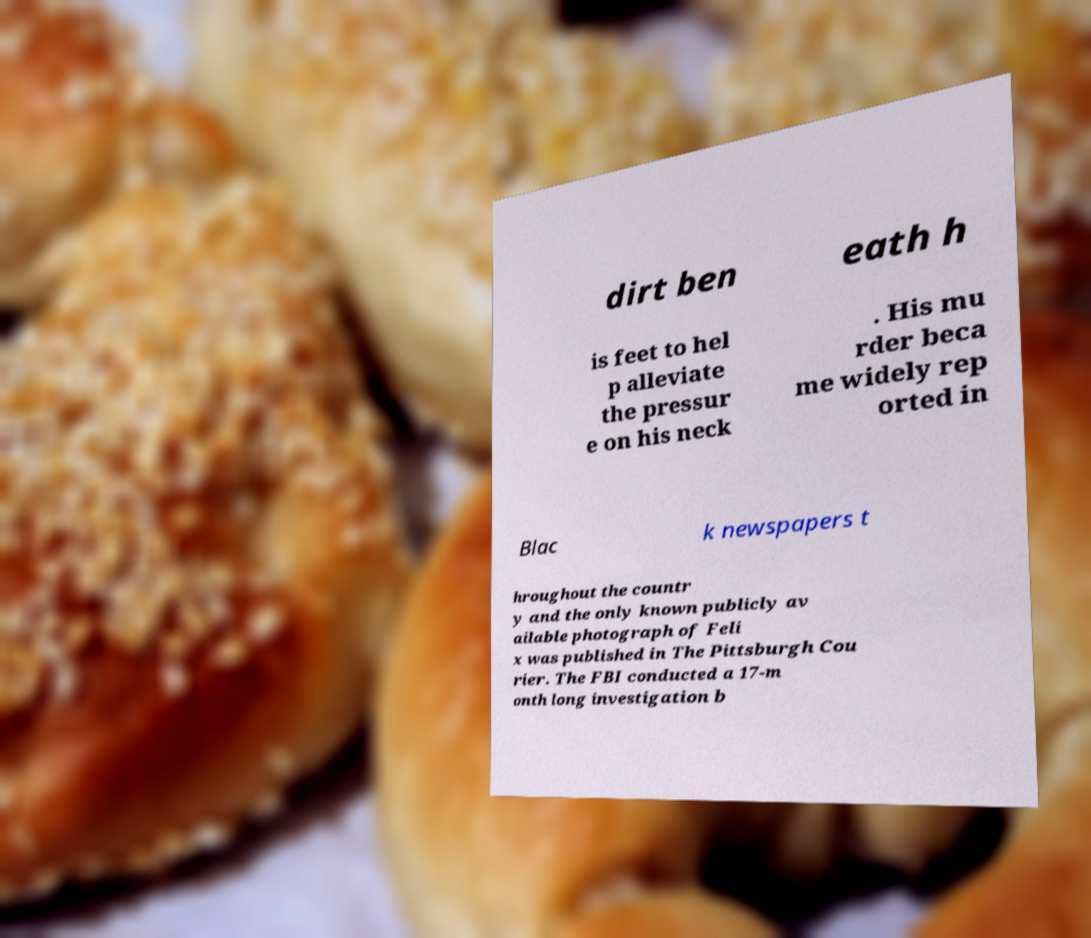Could you assist in decoding the text presented in this image and type it out clearly? dirt ben eath h is feet to hel p alleviate the pressur e on his neck . His mu rder beca me widely rep orted in Blac k newspapers t hroughout the countr y and the only known publicly av ailable photograph of Feli x was published in The Pittsburgh Cou rier. The FBI conducted a 17-m onth long investigation b 